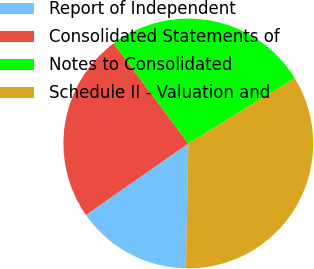Convert chart. <chart><loc_0><loc_0><loc_500><loc_500><pie_chart><fcel>Report of Independent<fcel>Consolidated Statements of<fcel>Notes to Consolidated<fcel>Schedule II - Valuation and<nl><fcel>14.99%<fcel>24.52%<fcel>26.43%<fcel>34.06%<nl></chart> 